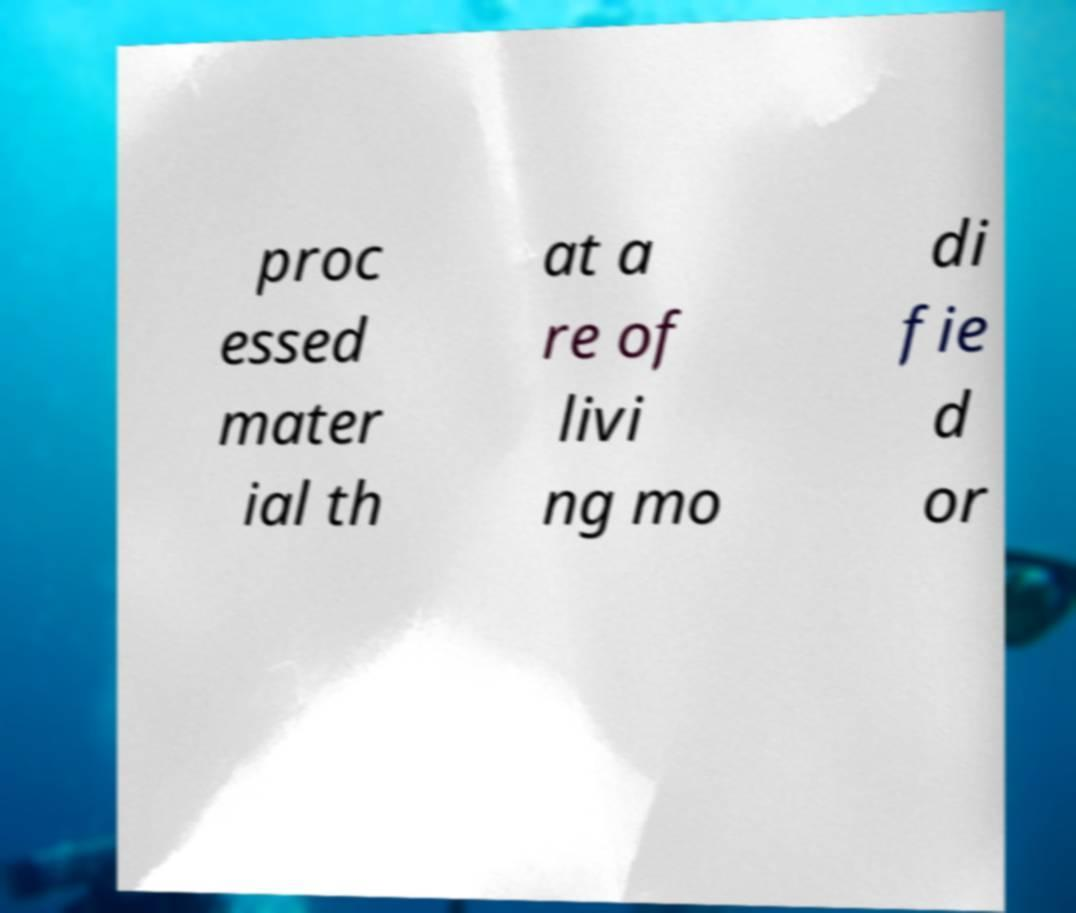For documentation purposes, I need the text within this image transcribed. Could you provide that? proc essed mater ial th at a re of livi ng mo di fie d or 